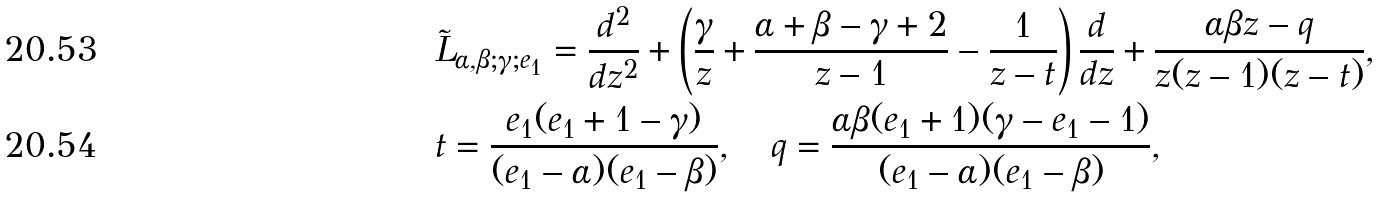<formula> <loc_0><loc_0><loc_500><loc_500>& \tilde { L } _ { \alpha , \beta ; \gamma ; e _ { 1 } } = \frac { d ^ { 2 } } { d z ^ { 2 } } + \left ( \frac { \gamma } { z } + \frac { \alpha + \beta - \gamma + 2 } { z - 1 } - \frac { 1 } { z - t } \right ) \frac { d } { d z } + \frac { \alpha \beta z - q } { z ( z - 1 ) ( z - t ) } , \\ & t = \frac { e _ { 1 } ( e _ { 1 } + 1 - \gamma ) } { ( e _ { 1 } - \alpha ) ( e _ { 1 } - \beta ) } , \quad q = \frac { \alpha \beta ( e _ { 1 } + 1 ) ( \gamma - e _ { 1 } - 1 ) } { ( e _ { 1 } - \alpha ) ( e _ { 1 } - \beta ) } ,</formula> 